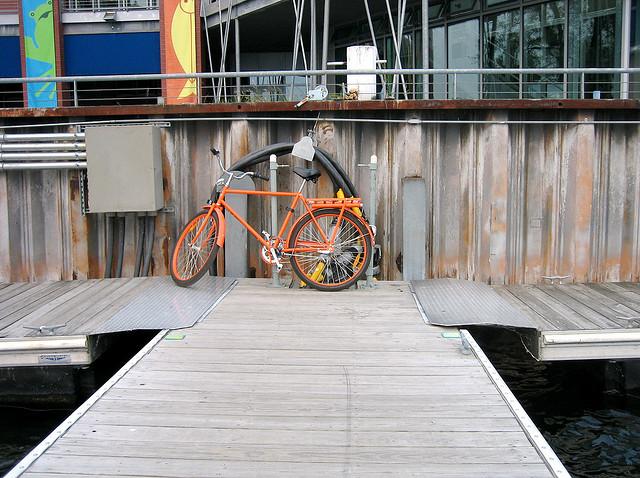What color is the bike?
Quick response, please. Orange. Could this be on a Wharf?
Write a very short answer. Yes. Is this a pier?
Give a very brief answer. Yes. 